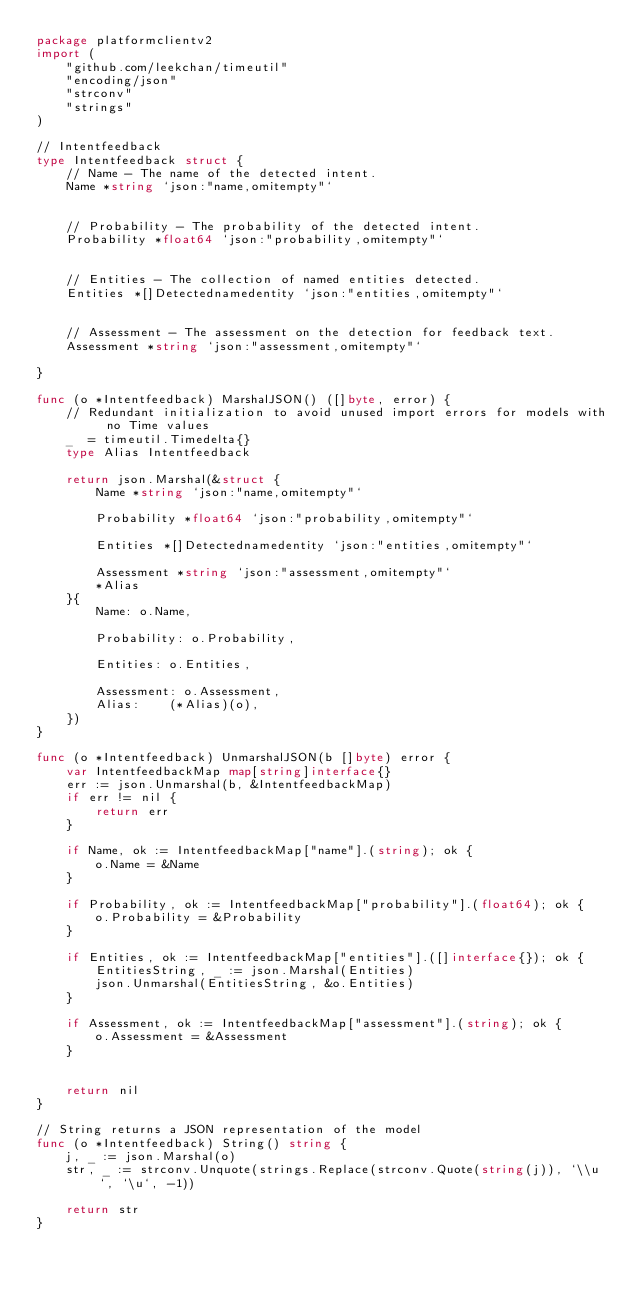Convert code to text. <code><loc_0><loc_0><loc_500><loc_500><_Go_>package platformclientv2
import (
	"github.com/leekchan/timeutil"
	"encoding/json"
	"strconv"
	"strings"
)

// Intentfeedback
type Intentfeedback struct { 
	// Name - The name of the detected intent.
	Name *string `json:"name,omitempty"`


	// Probability - The probability of the detected intent.
	Probability *float64 `json:"probability,omitempty"`


	// Entities - The collection of named entities detected.
	Entities *[]Detectednamedentity `json:"entities,omitempty"`


	// Assessment - The assessment on the detection for feedback text.
	Assessment *string `json:"assessment,omitempty"`

}

func (o *Intentfeedback) MarshalJSON() ([]byte, error) {
	// Redundant initialization to avoid unused import errors for models with no Time values
	_  = timeutil.Timedelta{}
	type Alias Intentfeedback
	
	return json.Marshal(&struct { 
		Name *string `json:"name,omitempty"`
		
		Probability *float64 `json:"probability,omitempty"`
		
		Entities *[]Detectednamedentity `json:"entities,omitempty"`
		
		Assessment *string `json:"assessment,omitempty"`
		*Alias
	}{ 
		Name: o.Name,
		
		Probability: o.Probability,
		
		Entities: o.Entities,
		
		Assessment: o.Assessment,
		Alias:    (*Alias)(o),
	})
}

func (o *Intentfeedback) UnmarshalJSON(b []byte) error {
	var IntentfeedbackMap map[string]interface{}
	err := json.Unmarshal(b, &IntentfeedbackMap)
	if err != nil {
		return err
	}
	
	if Name, ok := IntentfeedbackMap["name"].(string); ok {
		o.Name = &Name
	}
	
	if Probability, ok := IntentfeedbackMap["probability"].(float64); ok {
		o.Probability = &Probability
	}
	
	if Entities, ok := IntentfeedbackMap["entities"].([]interface{}); ok {
		EntitiesString, _ := json.Marshal(Entities)
		json.Unmarshal(EntitiesString, &o.Entities)
	}
	
	if Assessment, ok := IntentfeedbackMap["assessment"].(string); ok {
		o.Assessment = &Assessment
	}
	

	return nil
}

// String returns a JSON representation of the model
func (o *Intentfeedback) String() string {
	j, _ := json.Marshal(o)
	str, _ := strconv.Unquote(strings.Replace(strconv.Quote(string(j)), `\\u`, `\u`, -1))

	return str
}
</code> 